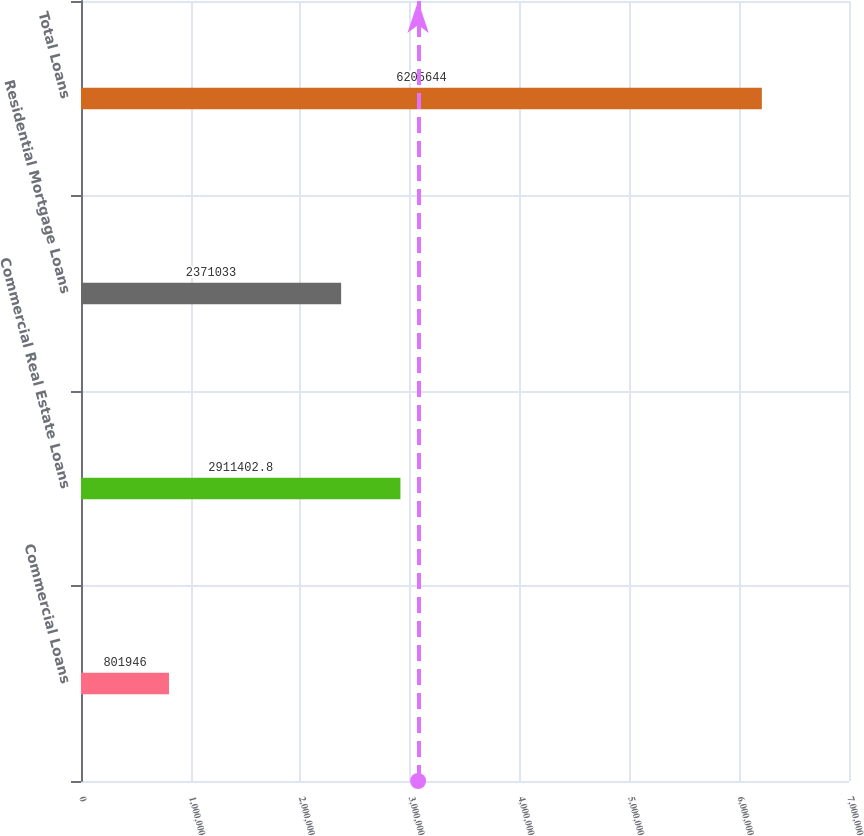<chart> <loc_0><loc_0><loc_500><loc_500><bar_chart><fcel>Commercial Loans<fcel>Commercial Real Estate Loans<fcel>Residential Mortgage Loans<fcel>Total Loans<nl><fcel>801946<fcel>2.9114e+06<fcel>2.37103e+06<fcel>6.20564e+06<nl></chart> 